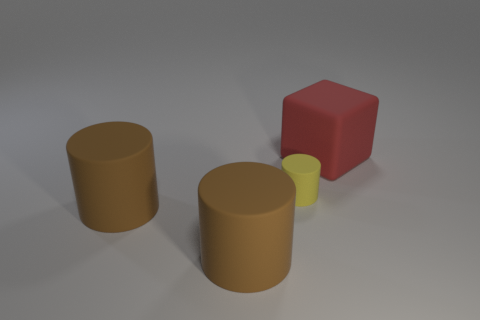Add 1 brown cylinders. How many objects exist? 5 Subtract all blocks. How many objects are left? 3 Subtract 0 brown cubes. How many objects are left? 4 Subtract all red blocks. Subtract all tiny green rubber cylinders. How many objects are left? 3 Add 3 brown cylinders. How many brown cylinders are left? 5 Add 3 cylinders. How many cylinders exist? 6 